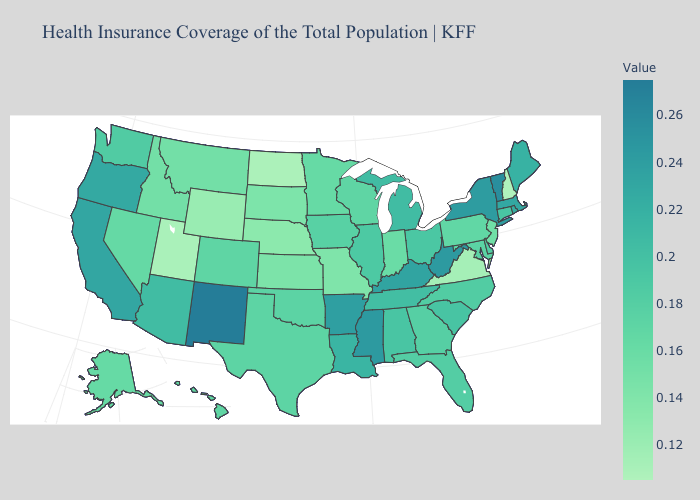Does the map have missing data?
Quick response, please. No. Among the states that border Arizona , which have the highest value?
Be succinct. New Mexico. Does Texas have the highest value in the USA?
Concise answer only. No. Among the states that border Maryland , does Delaware have the highest value?
Concise answer only. No. Among the states that border Tennessee , which have the lowest value?
Give a very brief answer. Virginia. Which states have the lowest value in the West?
Answer briefly. Utah. 